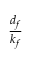Convert formula to latex. <formula><loc_0><loc_0><loc_500><loc_500>\frac { d _ { f } } { k _ { f } }</formula> 